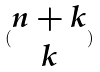Convert formula to latex. <formula><loc_0><loc_0><loc_500><loc_500>( \begin{matrix} n + k \\ k \end{matrix} )</formula> 